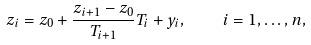Convert formula to latex. <formula><loc_0><loc_0><loc_500><loc_500>z _ { i } = z _ { 0 } + \frac { z _ { i + 1 } - z _ { 0 } } { T _ { i + 1 } } T _ { i } + y _ { i } , \quad i = 1 , \dots , n ,</formula> 